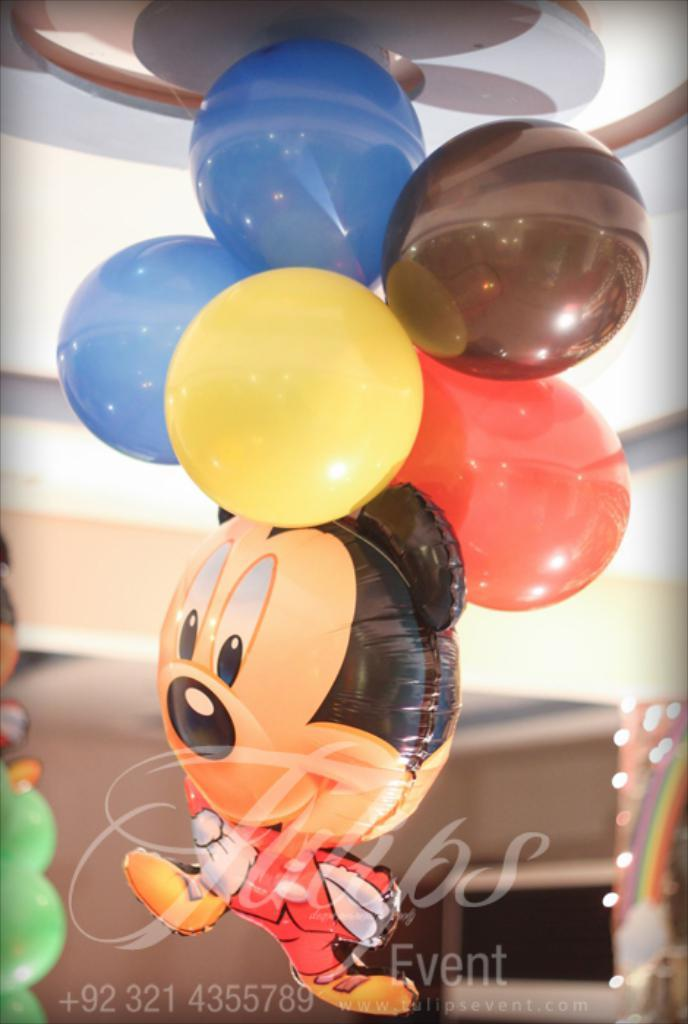What objects are present in the image? There are balloons in the image. Where are the balloons located? The balloons are stuck to a rooftop. Is there any text visible in the image? Yes, there is text visible at the bottom of the image. How is the distribution of the balloons managed in the image? There is no information provided about the distribution of the balloons in the image. --- Facts: 1. There is a person sitting on a bench in the image. 2. The person is reading a book. 3. There is a tree in the background of the image. 4. The person is wearing a hat. Absurd Topics: parrot, bicycle, ocean Conversation: What is the person in the image doing? The person is sitting on a bench and reading a book. What is visible in the background of the image? There is a tree in the background of the image. What accessory is the person wearing? The person is wearing a hat. Reasoning: Let's think step by step in order to produce the conversation. We start by identifying the main subject in the image, which is the person sitting on the bench. Then, we expand the conversation to include the person's activity, which is reading a book. Next, we mention the presence of a tree in the background. Finally, we note the person's accessory, which is a hat. Each question is designed to elicit a specific detail about the image that is known from the provided facts. Absurd Question/Answer: Can you see a parrot perched on the bicycle near the ocean in the image? There is no bicycle, parrot, or ocean present in the image. 